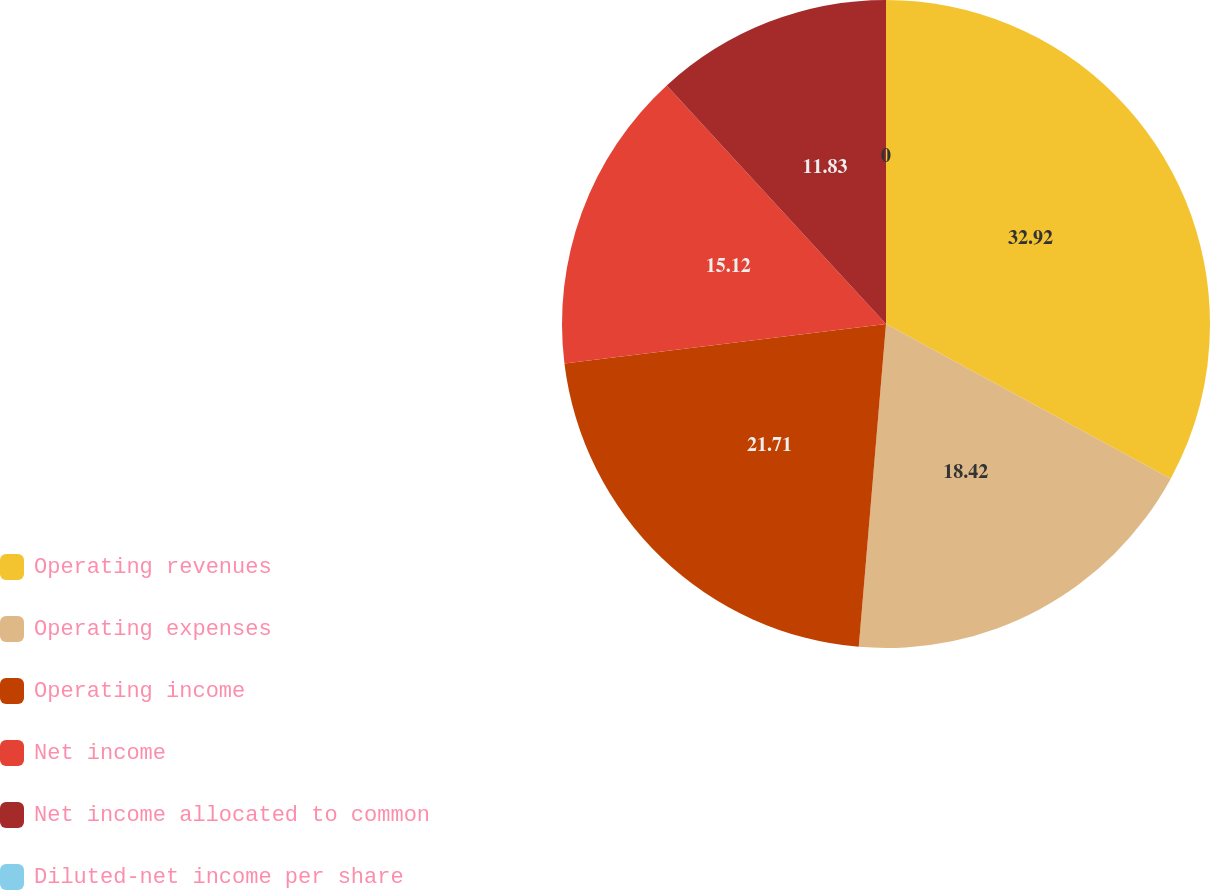Convert chart. <chart><loc_0><loc_0><loc_500><loc_500><pie_chart><fcel>Operating revenues<fcel>Operating expenses<fcel>Operating income<fcel>Net income<fcel>Net income allocated to common<fcel>Diluted-net income per share<nl><fcel>32.92%<fcel>18.42%<fcel>21.71%<fcel>15.12%<fcel>11.83%<fcel>0.0%<nl></chart> 